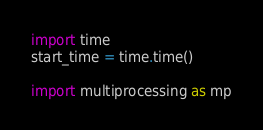<code> <loc_0><loc_0><loc_500><loc_500><_Python_>import time
start_time = time.time()

import multiprocessing as mp</code> 